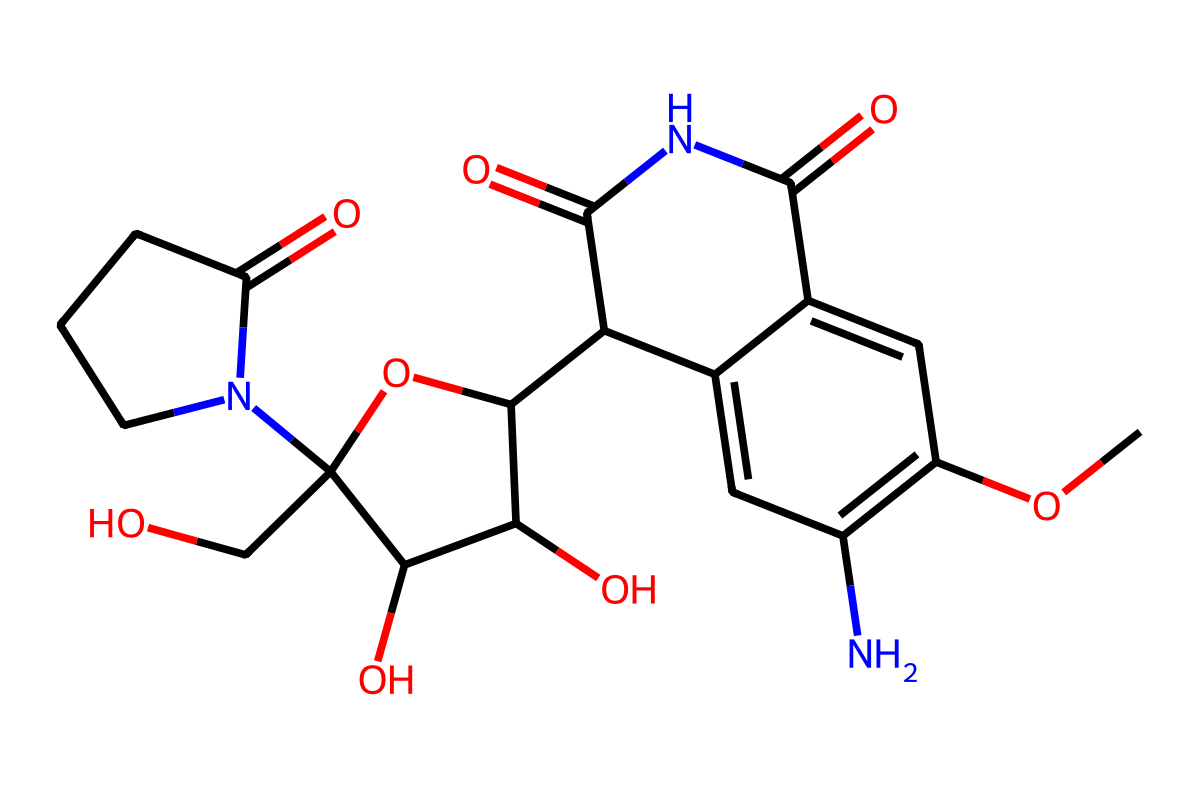What is the molecular formula of this antibiotic? To find the molecular formula, we need to count the number of each type of atom present in the structure represented by the SMILES notation. Upon analyzing, we identify that the structure contains 22 carbon (C) atoms, 30 hydrogen (H) atoms, 4 nitrogen (N) atoms, and 5 oxygen (O) atoms. Thus, the molecular formula is C22H30N4O5.
Answer: C22H30N4O5 How many rings are present in this structure? By examining the SMILES notation, we can see the presence of cyclic structures. There are two indicated rings (C1 and C2) in the structure, confirming that there are two rings.
Answer: 2 What functional groups are present in this antibiotic? The analysis of the SMILES reveals multiple functional groups: a carbonyl group (C=O), an amino group (NH), and several hydroxyl groups (OH). Together, these groups define the reactivity and properties of the antibiotic.
Answer: carbonyl, amino, hydroxyl What type of antibiotic is this structure? This structure is characteristic of a class of antibiotics known as cephalosporins, which contain a beta-lactam ring and are used for their antibacterial properties.
Answer: cephalosporin What is the total number of heteroatoms in the molecule? Heteroatoms are atoms in a molecule that are not carbon or hydrogen. By analyzing the SMILES, we identify the total number of heteroatoms: nitrogen (N) and oxygen (O). There are 4 nitrogen atoms and 5 oxygen atoms, resulting in a total of 9 heteroatoms.
Answer: 9 Which part of the structure contributes to the antibiotic activity? The beta-lactam ring is crucial for the antibiotic activity, as it plays a significant role in inhibiting bacterial cell wall synthesis. This specific structure allows for binding to penicillin-binding proteins.
Answer: beta-lactam ring 